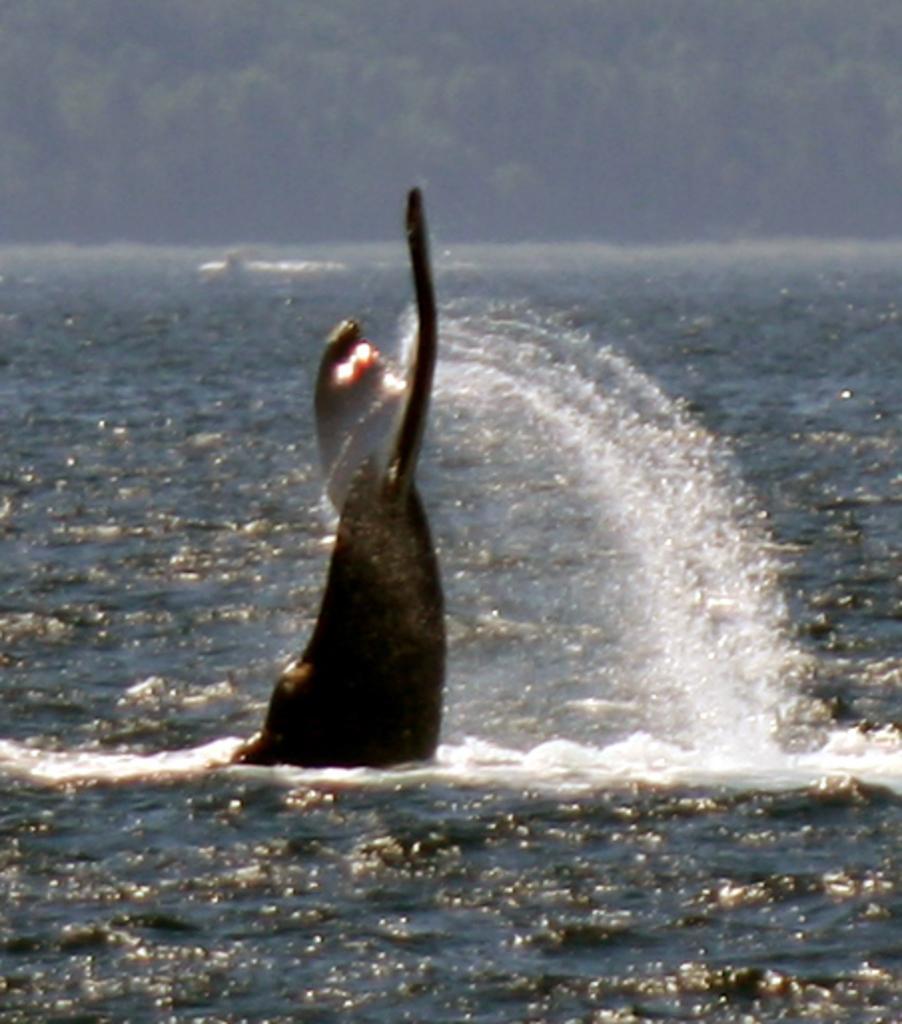In one or two sentences, can you explain what this image depicts? In this picture we can see water and in the background we can see trees. 